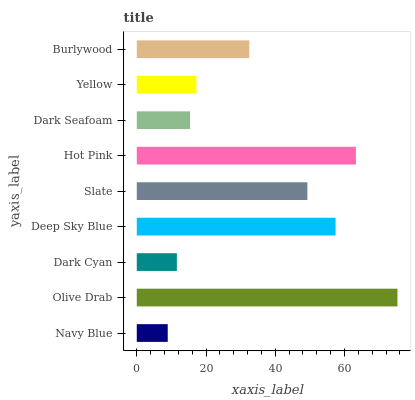Is Navy Blue the minimum?
Answer yes or no. Yes. Is Olive Drab the maximum?
Answer yes or no. Yes. Is Dark Cyan the minimum?
Answer yes or no. No. Is Dark Cyan the maximum?
Answer yes or no. No. Is Olive Drab greater than Dark Cyan?
Answer yes or no. Yes. Is Dark Cyan less than Olive Drab?
Answer yes or no. Yes. Is Dark Cyan greater than Olive Drab?
Answer yes or no. No. Is Olive Drab less than Dark Cyan?
Answer yes or no. No. Is Burlywood the high median?
Answer yes or no. Yes. Is Burlywood the low median?
Answer yes or no. Yes. Is Yellow the high median?
Answer yes or no. No. Is Dark Cyan the low median?
Answer yes or no. No. 